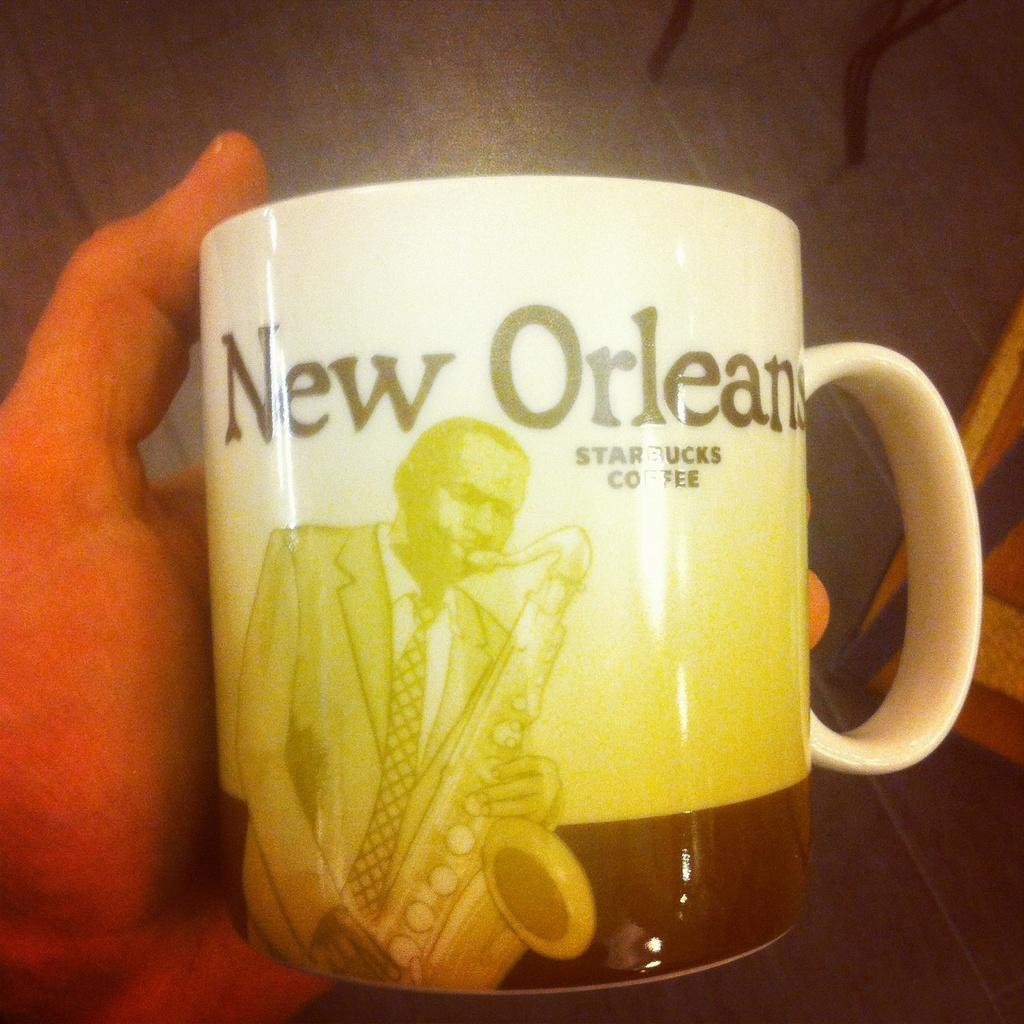<image>
Offer a succinct explanation of the picture presented. A coffee mug from Starbucks coffee with a sax player from New Orleans on it. 